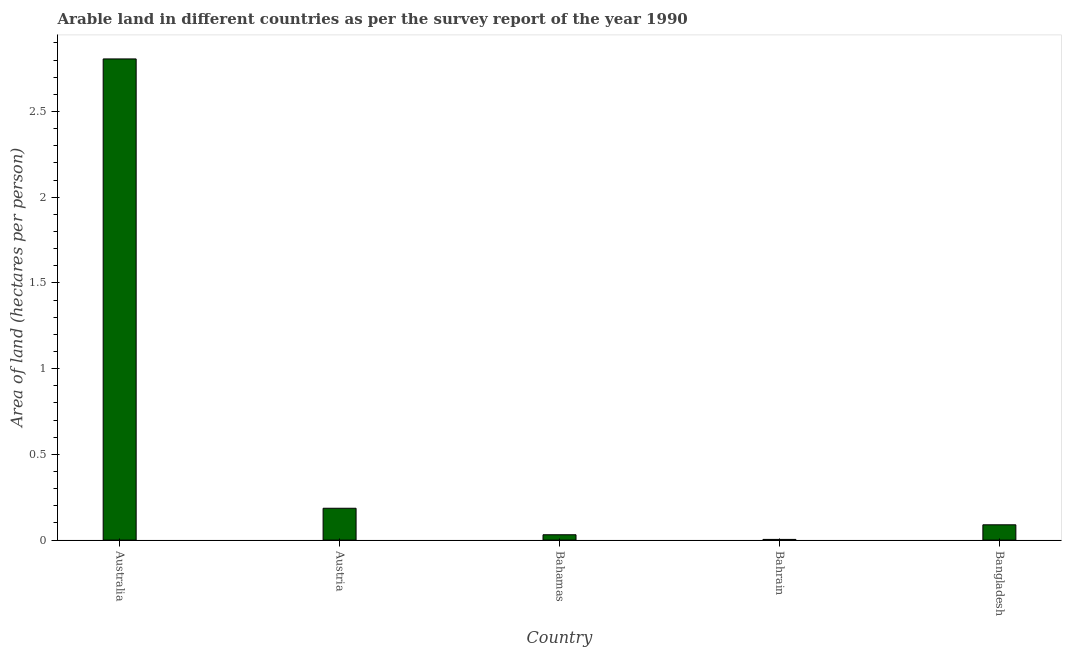Does the graph contain any zero values?
Keep it short and to the point. No. What is the title of the graph?
Keep it short and to the point. Arable land in different countries as per the survey report of the year 1990. What is the label or title of the X-axis?
Keep it short and to the point. Country. What is the label or title of the Y-axis?
Offer a very short reply. Area of land (hectares per person). What is the area of arable land in Bahamas?
Your response must be concise. 0.03. Across all countries, what is the maximum area of arable land?
Provide a short and direct response. 2.81. Across all countries, what is the minimum area of arable land?
Provide a succinct answer. 0. In which country was the area of arable land minimum?
Your answer should be very brief. Bahrain. What is the sum of the area of arable land?
Offer a very short reply. 3.12. What is the difference between the area of arable land in Austria and Bahrain?
Offer a terse response. 0.18. What is the average area of arable land per country?
Make the answer very short. 0.62. What is the median area of arable land?
Your answer should be compact. 0.09. What is the ratio of the area of arable land in Australia to that in Bangladesh?
Offer a very short reply. 31.46. Is the area of arable land in Bahamas less than that in Bahrain?
Offer a terse response. No. What is the difference between the highest and the second highest area of arable land?
Give a very brief answer. 2.62. Is the sum of the area of arable land in Australia and Bahamas greater than the maximum area of arable land across all countries?
Offer a terse response. Yes. Are the values on the major ticks of Y-axis written in scientific E-notation?
Keep it short and to the point. No. What is the Area of land (hectares per person) of Australia?
Your answer should be very brief. 2.81. What is the Area of land (hectares per person) in Austria?
Your answer should be compact. 0.19. What is the Area of land (hectares per person) of Bahamas?
Offer a terse response. 0.03. What is the Area of land (hectares per person) in Bahrain?
Your response must be concise. 0. What is the Area of land (hectares per person) of Bangladesh?
Offer a very short reply. 0.09. What is the difference between the Area of land (hectares per person) in Australia and Austria?
Your answer should be compact. 2.62. What is the difference between the Area of land (hectares per person) in Australia and Bahamas?
Your answer should be compact. 2.78. What is the difference between the Area of land (hectares per person) in Australia and Bahrain?
Your response must be concise. 2.8. What is the difference between the Area of land (hectares per person) in Australia and Bangladesh?
Provide a short and direct response. 2.72. What is the difference between the Area of land (hectares per person) in Austria and Bahamas?
Your answer should be very brief. 0.15. What is the difference between the Area of land (hectares per person) in Austria and Bahrain?
Offer a terse response. 0.18. What is the difference between the Area of land (hectares per person) in Austria and Bangladesh?
Ensure brevity in your answer.  0.1. What is the difference between the Area of land (hectares per person) in Bahamas and Bahrain?
Ensure brevity in your answer.  0.03. What is the difference between the Area of land (hectares per person) in Bahamas and Bangladesh?
Your response must be concise. -0.06. What is the difference between the Area of land (hectares per person) in Bahrain and Bangladesh?
Your answer should be compact. -0.09. What is the ratio of the Area of land (hectares per person) in Australia to that in Austria?
Keep it short and to the point. 15.11. What is the ratio of the Area of land (hectares per person) in Australia to that in Bahamas?
Make the answer very short. 89.94. What is the ratio of the Area of land (hectares per person) in Australia to that in Bahrain?
Your answer should be compact. 696.03. What is the ratio of the Area of land (hectares per person) in Australia to that in Bangladesh?
Your answer should be compact. 31.46. What is the ratio of the Area of land (hectares per person) in Austria to that in Bahamas?
Provide a succinct answer. 5.95. What is the ratio of the Area of land (hectares per person) in Austria to that in Bahrain?
Provide a short and direct response. 46.06. What is the ratio of the Area of land (hectares per person) in Austria to that in Bangladesh?
Your answer should be very brief. 2.08. What is the ratio of the Area of land (hectares per person) in Bahamas to that in Bahrain?
Give a very brief answer. 7.74. What is the ratio of the Area of land (hectares per person) in Bahamas to that in Bangladesh?
Offer a very short reply. 0.35. What is the ratio of the Area of land (hectares per person) in Bahrain to that in Bangladesh?
Your answer should be very brief. 0.04. 